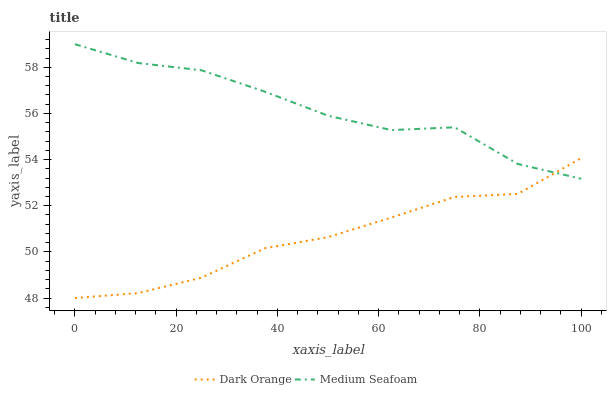Does Dark Orange have the minimum area under the curve?
Answer yes or no. Yes. Does Medium Seafoam have the maximum area under the curve?
Answer yes or no. Yes. Does Medium Seafoam have the minimum area under the curve?
Answer yes or no. No. Is Dark Orange the smoothest?
Answer yes or no. Yes. Is Medium Seafoam the roughest?
Answer yes or no. Yes. Is Medium Seafoam the smoothest?
Answer yes or no. No. Does Dark Orange have the lowest value?
Answer yes or no. Yes. Does Medium Seafoam have the lowest value?
Answer yes or no. No. Does Medium Seafoam have the highest value?
Answer yes or no. Yes. Does Dark Orange intersect Medium Seafoam?
Answer yes or no. Yes. Is Dark Orange less than Medium Seafoam?
Answer yes or no. No. Is Dark Orange greater than Medium Seafoam?
Answer yes or no. No. 